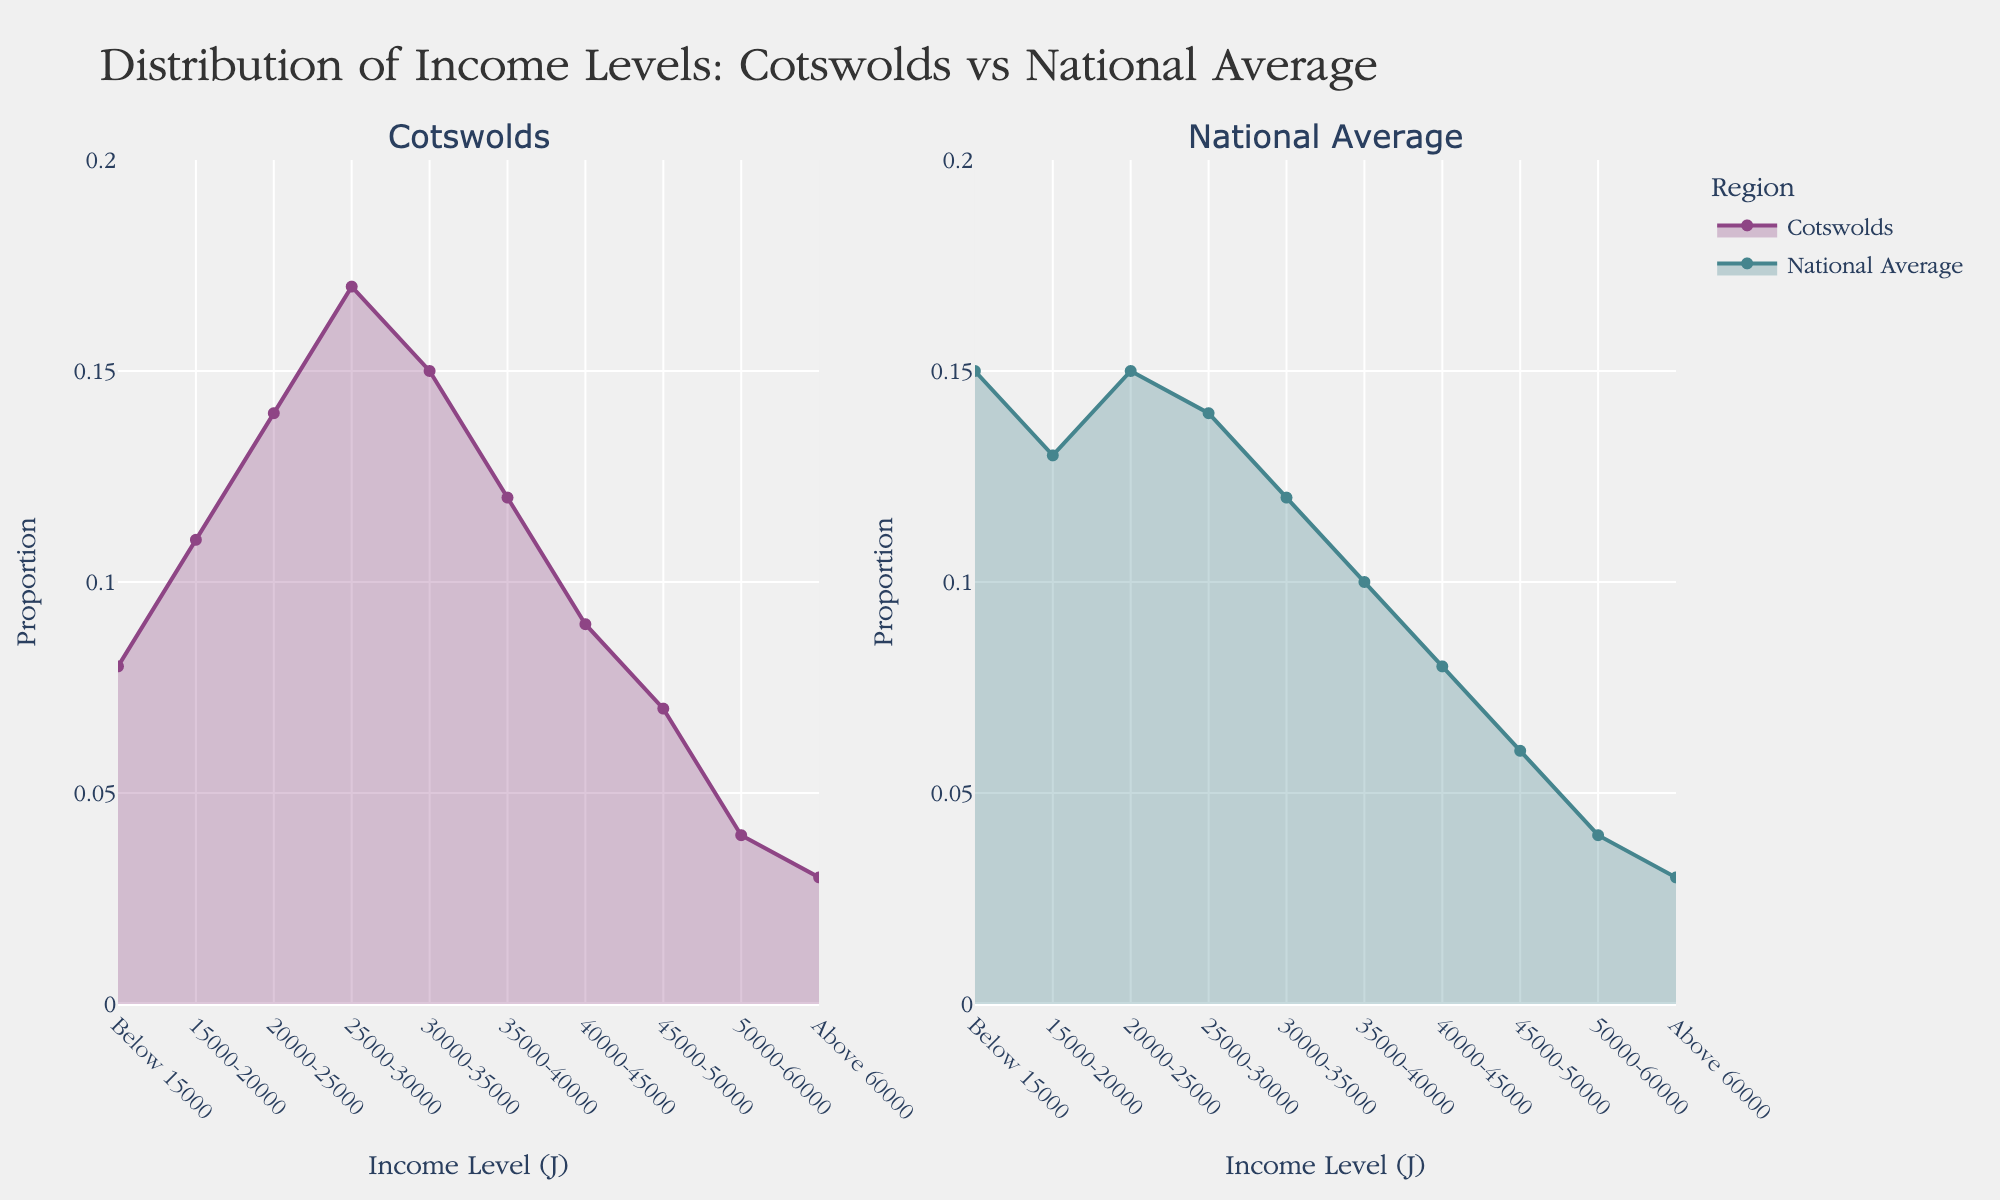How many subplots are present in the figure? There are two subplots present in the figure: one for the Cotswolds and one for the National Average.
Answer: Two What is the title of the overall plot? The title is located at the top of the figure and reads: "Distribution of Income Levels: Cotswolds vs National Average".
Answer: Distribution of Income Levels: Cotswolds vs National Average Which income level has the highest proportion in the Cotswolds? By looking at the height of the density plot in the Cotswolds subplot, the income level with the highest proportion is £25000-30000.
Answer: £25,000-£30,000 How do the proportions of residents earning below £15,000 compare between the Cotswolds and the national average? In the Cotswolds subplot, the proportion is 0.08, while in the National Average subplot, it is 0.15. Therefore, the national average has a higher proportion of residents earning below £15,000.
Answer: The national average is higher Which subplot has a greater variety of income levels, and how can you tell? Both subplots represent the same range of income levels as indicated by the x-axes, from "Below £15,000" to "Above £60,000." Therefore, neither subplot has a greater variety of income levels.
Answer: Neither What is the combined proportion of residents earning between £15,000 and £35,000 in the Cotswolds? To find the combined proportion, add the individual proportions for each respective income range: 0.11 (15k-20k) + 0.14 (20k-25k) + 0.17 (25k-30k) + 0.15 (30k-35k) = 0.57.
Answer: 0.57 Is the proportion of residents earning £35,000-£40,000 higher in the Cotswolds or the national average? In the Cotswolds subplot, the proportion for £35,000-£40,000 is 0.12, whereas in the National Average subplot it is 0.10. The Cotswolds has a higher proportion.
Answer: The Cotswolds What is the difference in proportion of residents earning £40,000-£45,000 between the Cotswolds and the national average? In the Cotswolds subplot, the proportion for this income level is 0.09. In the National Average subplot, it is 0.08. The difference is 0.09 - 0.08 = 0.01.
Answer: 0.01 Are there any income levels where the proportions are the same between the Cotswolds and the national average? By comparing both subplots, the income level "Above £60,000" has the same proportion in both the Cotswolds subplot and the National Average subplot, which is 0.03.
Answer: Above £60,000 